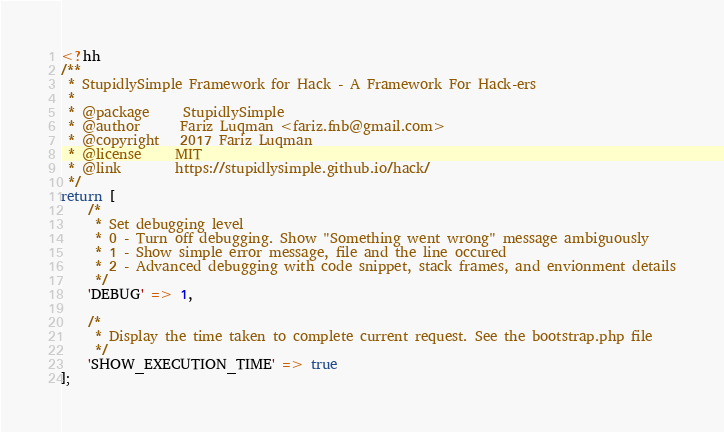<code> <loc_0><loc_0><loc_500><loc_500><_C++_><?hh
/**
 * StupidlySimple Framework for Hack - A Framework For Hack-ers
 *
 * @package		StupidlySimple
 * @author		Fariz Luqman <fariz.fnb@gmail.com>
 * @copyright	2017 Fariz Luqman
 * @license		MIT
 * @link		https://stupidlysimple.github.io/hack/
 */
return [
    /*
     * Set debugging level
     * 0 - Turn off debugging. Show "Something went wrong" message ambiguously
     * 1 - Show simple error message, file and the line occured
     * 2 - Advanced debugging with code snippet, stack frames, and envionment details
     */
    'DEBUG' => 1,

    /*
     * Display the time taken to complete current request. See the bootstrap.php file
     */
    'SHOW_EXECUTION_TIME' => true
];</code> 